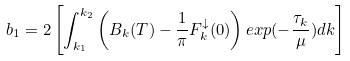Convert formula to latex. <formula><loc_0><loc_0><loc_500><loc_500>b _ { 1 } = 2 \left [ \int _ { k _ { 1 } } ^ { k _ { 2 } } \left ( B _ { k } ( T ) - \frac { 1 } { \pi } F _ { k } ^ { \downarrow } ( 0 ) \right ) e x p ( - \frac { \tau _ { k } } { \mu } ) d k \right ]</formula> 